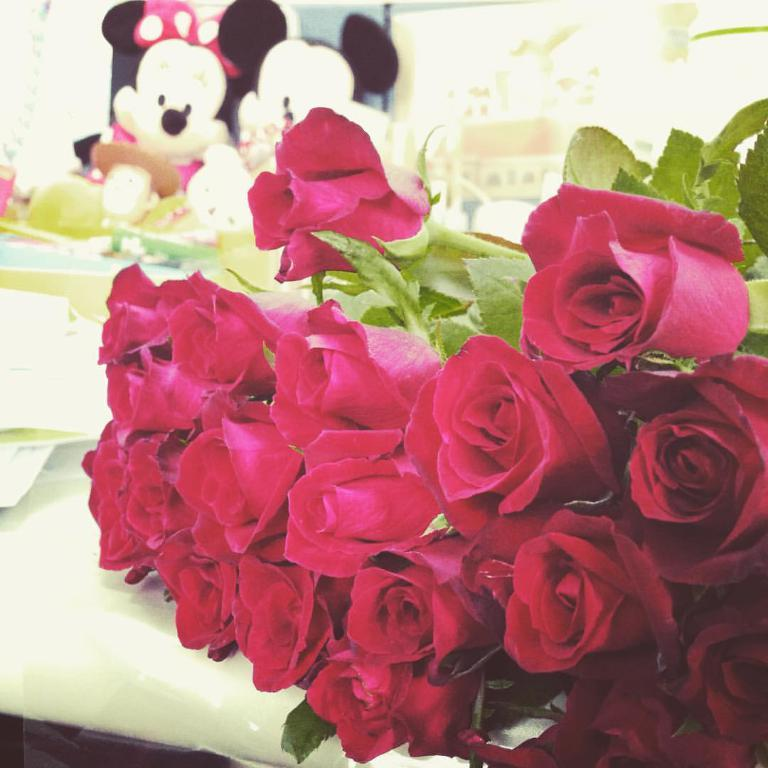What type of flowers are on the table in the image? There are red roses on the table in the image. What else is located near the red roses? There are papers beside the red roses. What can be seen near the window in the image? There are two toys near a window. What is visible through the window in the image? There is a building visible through the window. Can you see a ghost in the image? There is no ghost present in the image. What type of power is being generated in the image? There is no indication of power generation in the image. 